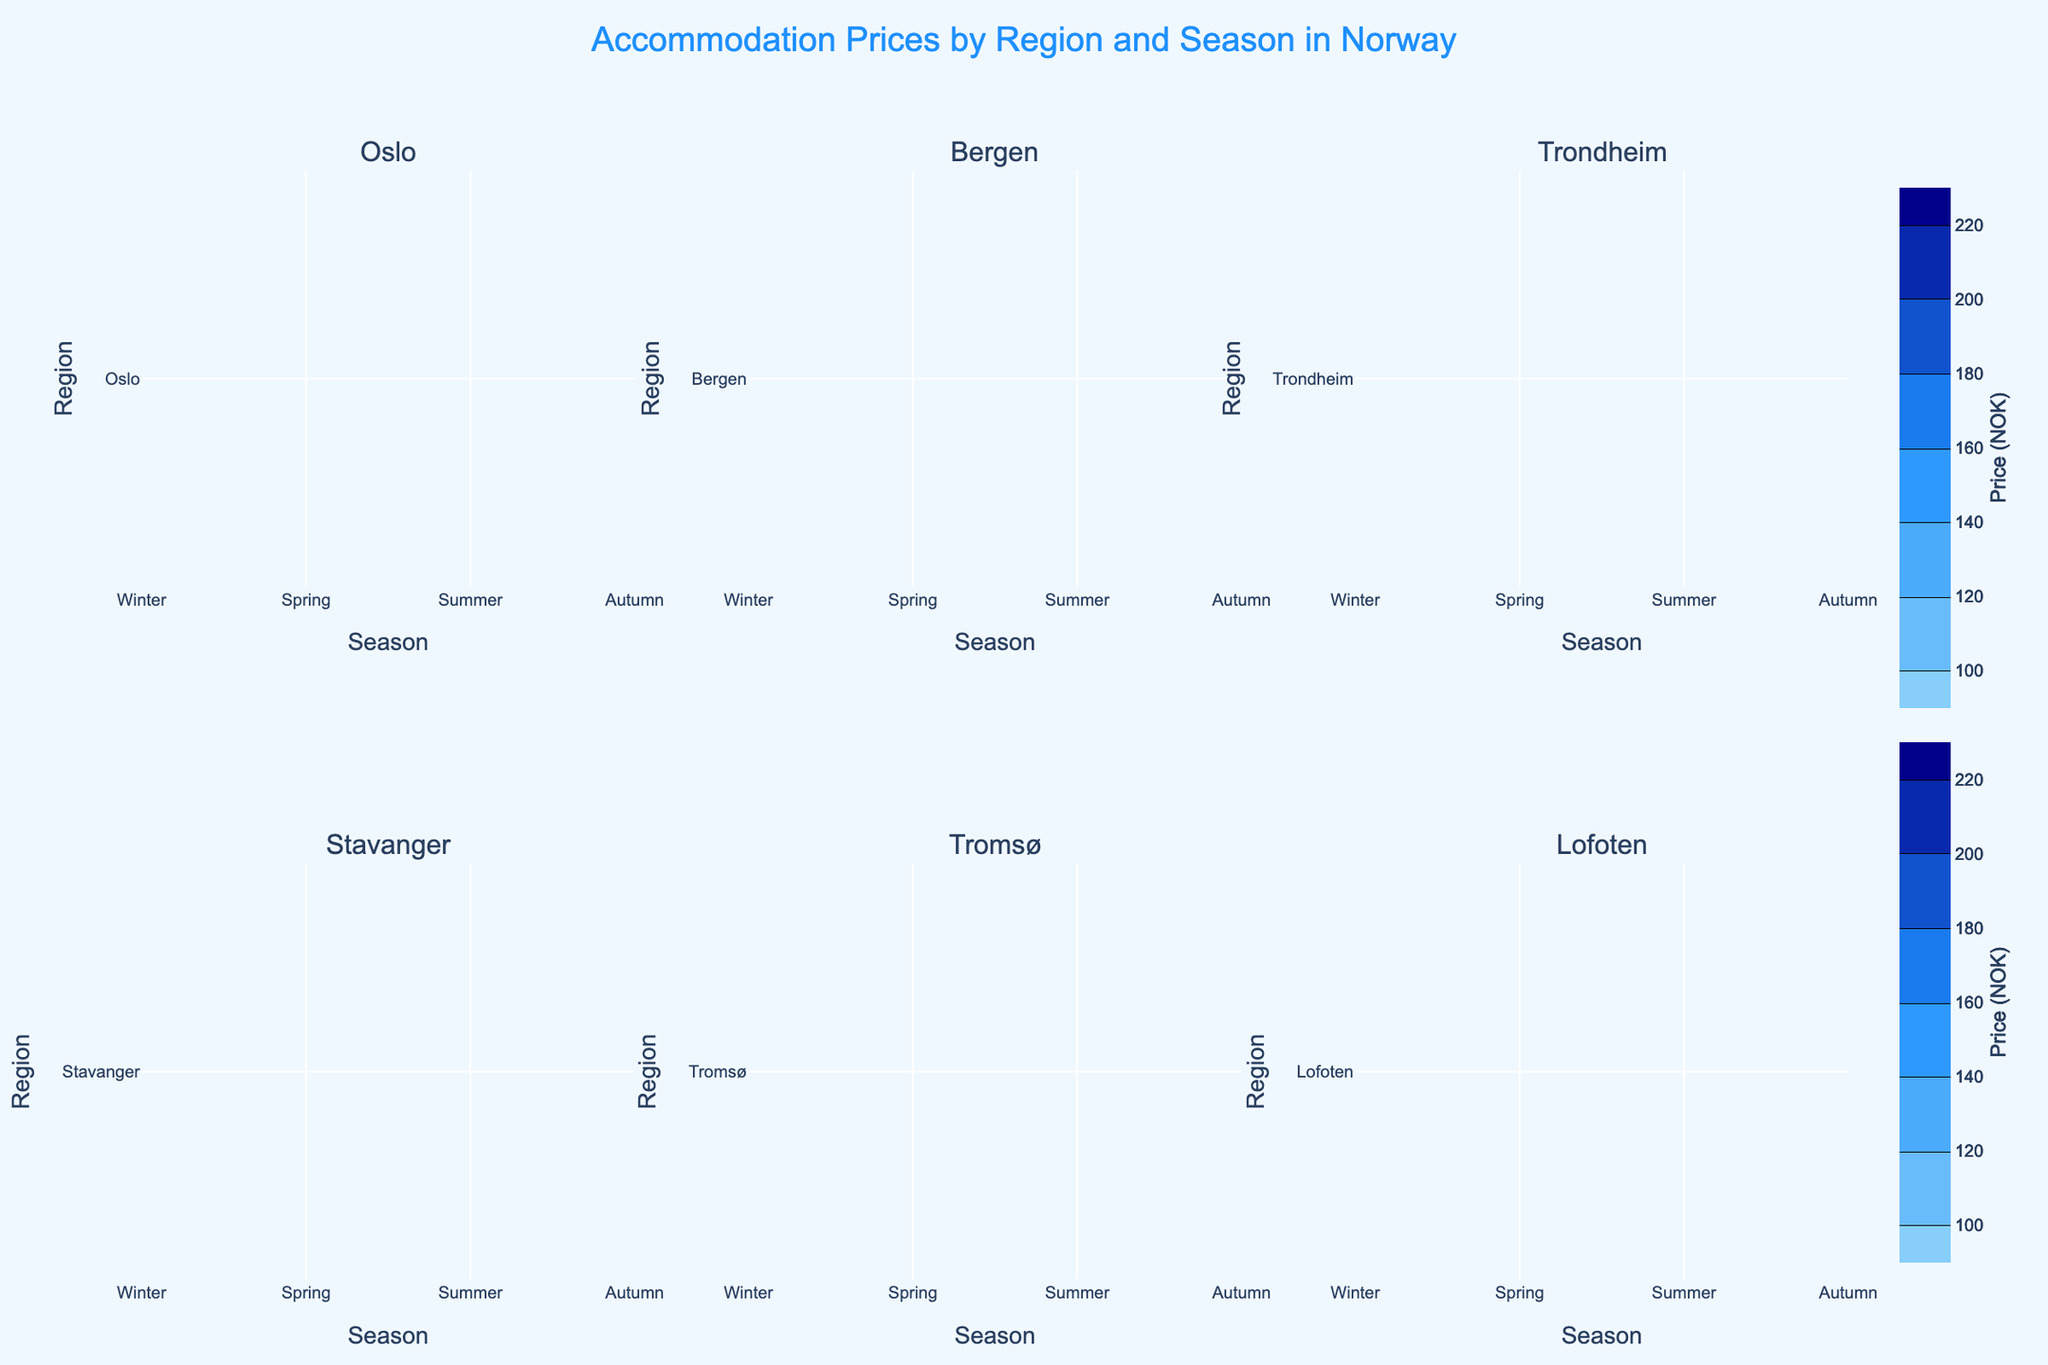How many regions are represented in the figure? Count the number of subplot titles, which correspond to the regions. There are six subplot titles: Oslo, Bergen, Trondheim, Stavanger, Tromsø, and Lofoten.
Answer: 6 Which season has the highest accommodation price in Tromsø? Look at the contour for Tromsø and identify which season has the highest value. The highest price appears under Summer with a value of 220 NOK.
Answer: Summer What is the price range for accommodations in Lofoten? Identify the minimum and maximum prices from the contour plot for Lofoten. The prices range from a low of 150 NOK in Spring to a high of 210 NOK in Summer.
Answer: 150-210 NOK Which region has the lowest price during Spring? Check each subplot for the Spring season and locate the lowest price. Trondheim has the lowest price during Spring at 105 NOK.
Answer: Trondheim What is the difference in accommodation price between Winter and Summer in Oslo? Locate the prices for Winter (150 NOK) and Summer (175 NOK) in Oslo and calculate the difference: 175 - 150 = 25 NOK.
Answer: 25 NOK Which region shows the smallest variation in accommodation prices across all seasons? Compare the price differences across all seasons for each region and identify the smallest range. Trondheim shows the smallest variation with prices ranging from 105 NOK to 150 NOK, a difference of 45 NOK.
Answer: Trondheim How does the Autumn price in Stavanger compare to the Autumn price in Bergen? Identify the Autumn prices in both regions and compare: Stavanger is 130 NOK, and Bergen is 120 NOK. Stavanger is more expensive by 10 NOK.
Answer: Stavanger is higher Which region's accommodation prices remain below 200 NOK in all seasons? For each region, check if any price exceeds 200 NOK. Trondheim meets this criterion as all prices are below 200 NOK.
Answer: Trondheim What is the average accommodation price in Bergen? Sum all prices in Bergen: 130 + 110 + 160 + 120 = 520 NOK. Divide by the number of seasons (4) to find the average: 520 / 4 = 130 NOK.
Answer: 130 NOK 